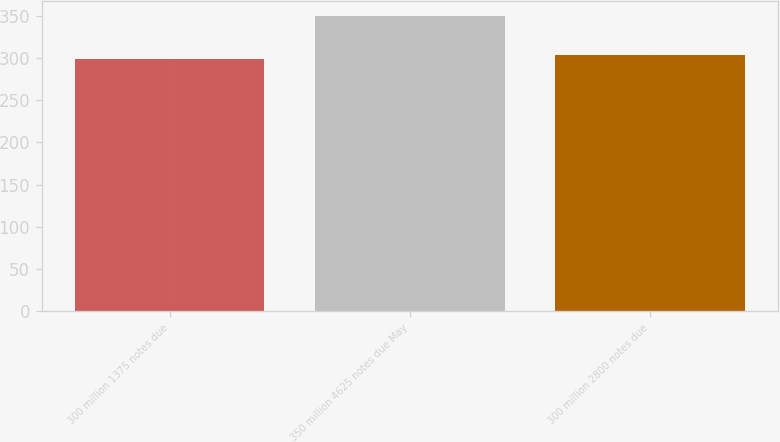Convert chart to OTSL. <chart><loc_0><loc_0><loc_500><loc_500><bar_chart><fcel>300 million 1375 notes due<fcel>350 million 4625 notes due May<fcel>300 million 2800 notes due<nl><fcel>299<fcel>349.8<fcel>304.08<nl></chart> 